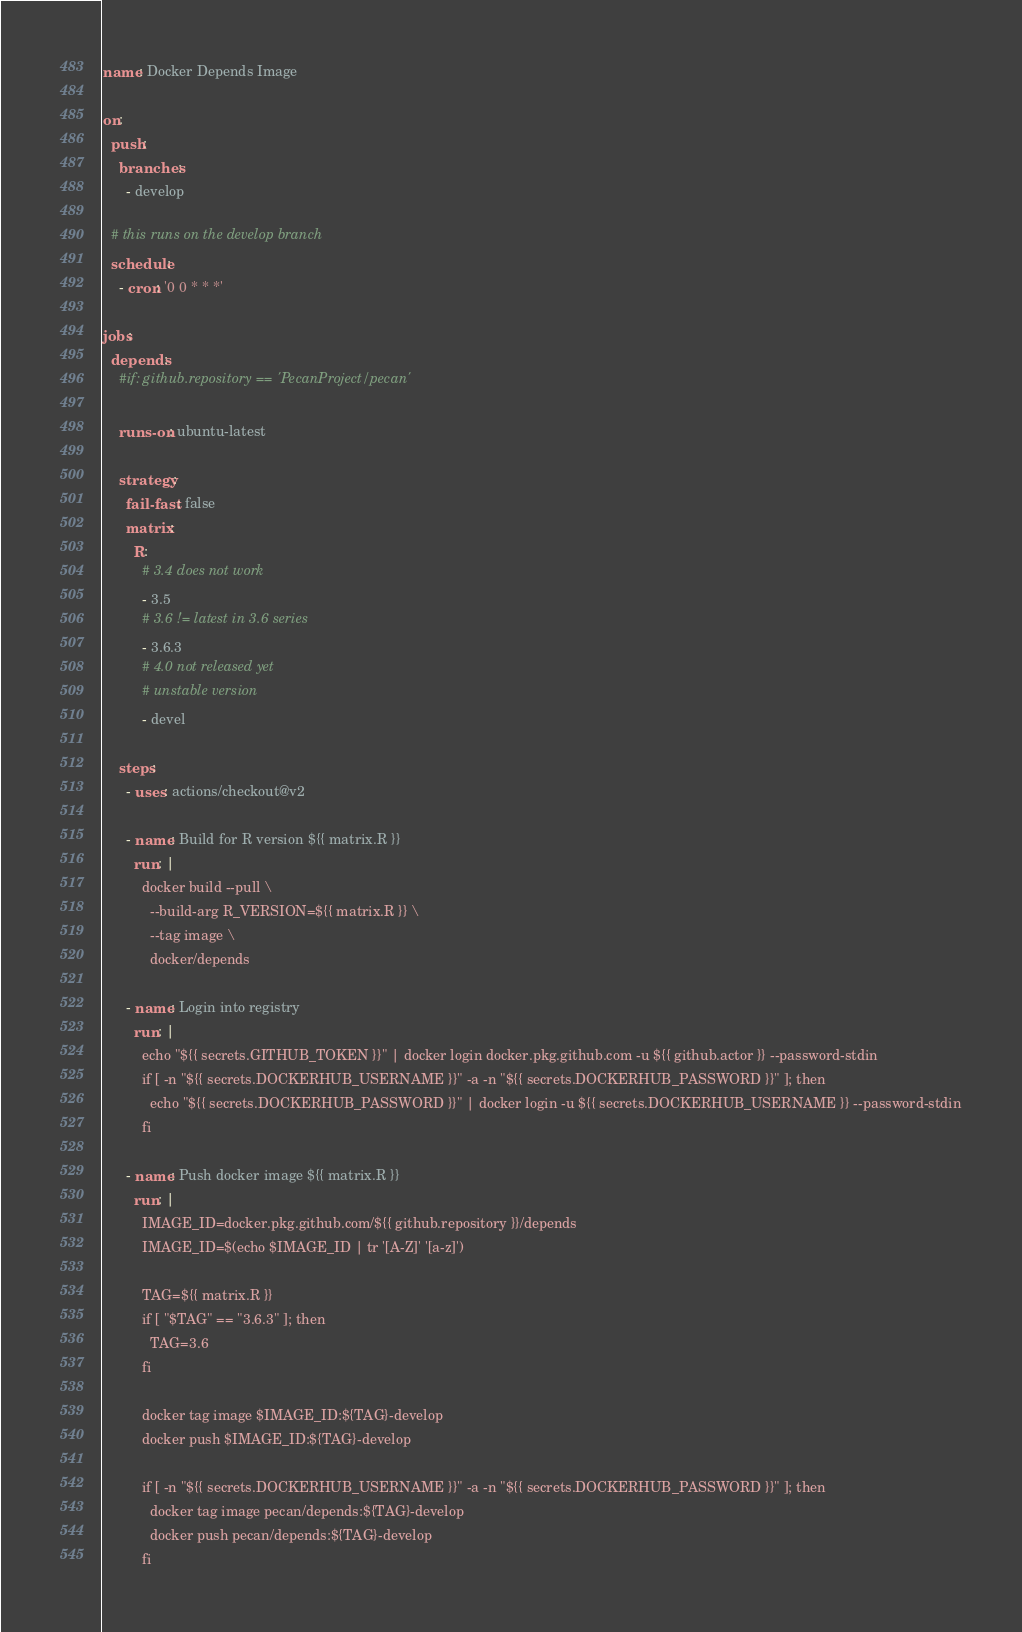Convert code to text. <code><loc_0><loc_0><loc_500><loc_500><_YAML_>name: Docker Depends Image

on:
  push:
    branches:
      - develop

  # this runs on the develop branch
  schedule:
    - cron: '0 0 * * *'

jobs:
  depends:
    #if: github.repository == 'PecanProject/pecan'

    runs-on: ubuntu-latest

    strategy:
      fail-fast: false
      matrix:
        R:
          # 3.4 does not work
          - 3.5
          # 3.6 != latest in 3.6 series
          - 3.6.3
          # 4.0 not released yet
          # unstable version
          - devel

    steps:
      - uses: actions/checkout@v2

      - name: Build for R version ${{ matrix.R }}
        run: |
          docker build --pull \
            --build-arg R_VERSION=${{ matrix.R }} \
            --tag image \
            docker/depends

      - name: Login into registry
        run: |
          echo "${{ secrets.GITHUB_TOKEN }}" | docker login docker.pkg.github.com -u ${{ github.actor }} --password-stdin
          if [ -n "${{ secrets.DOCKERHUB_USERNAME }}" -a -n "${{ secrets.DOCKERHUB_PASSWORD }}" ]; then
            echo "${{ secrets.DOCKERHUB_PASSWORD }}" | docker login -u ${{ secrets.DOCKERHUB_USERNAME }} --password-stdin
          fi

      - name: Push docker image ${{ matrix.R }}
        run: |
          IMAGE_ID=docker.pkg.github.com/${{ github.repository }}/depends
          IMAGE_ID=$(echo $IMAGE_ID | tr '[A-Z]' '[a-z]')

          TAG=${{ matrix.R }}
          if [ "$TAG" == "3.6.3" ]; then
            TAG=3.6
          fi

          docker tag image $IMAGE_ID:${TAG}-develop
          docker push $IMAGE_ID:${TAG}-develop

          if [ -n "${{ secrets.DOCKERHUB_USERNAME }}" -a -n "${{ secrets.DOCKERHUB_PASSWORD }}" ]; then
            docker tag image pecan/depends:${TAG}-develop
            docker push pecan/depends:${TAG}-develop
          fi
</code> 